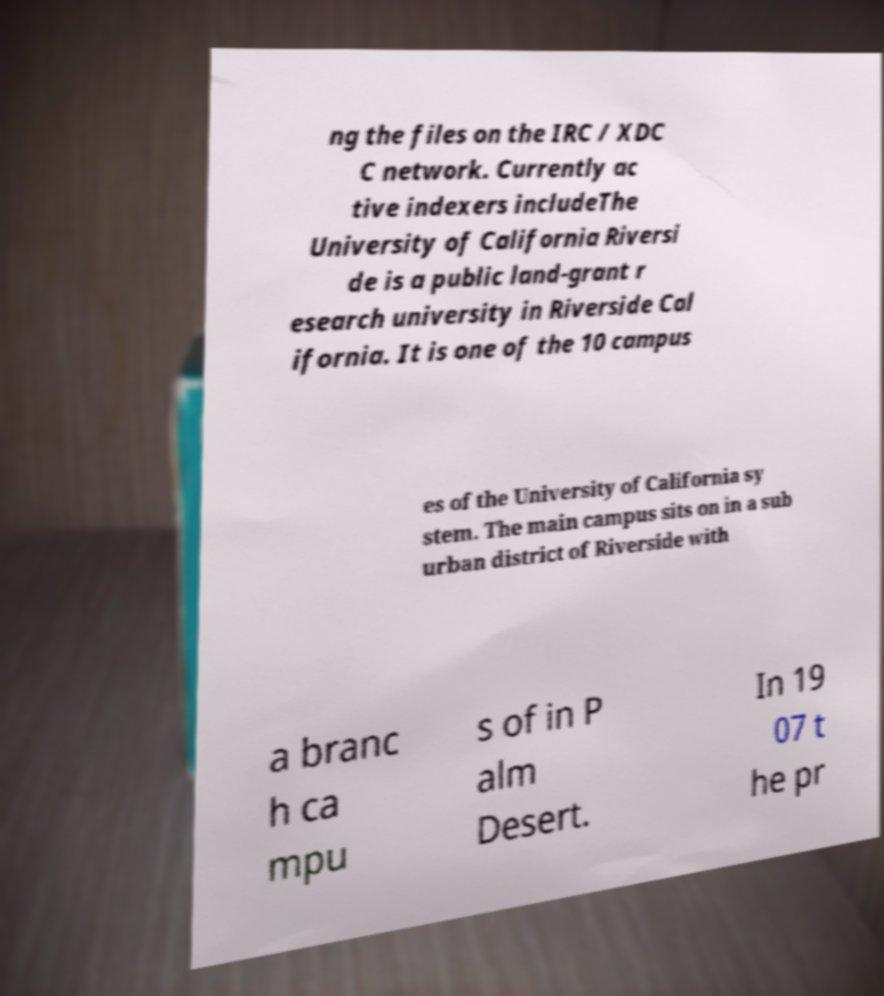Can you accurately transcribe the text from the provided image for me? ng the files on the IRC / XDC C network. Currently ac tive indexers includeThe University of California Riversi de is a public land-grant r esearch university in Riverside Cal ifornia. It is one of the 10 campus es of the University of California sy stem. The main campus sits on in a sub urban district of Riverside with a branc h ca mpu s of in P alm Desert. In 19 07 t he pr 